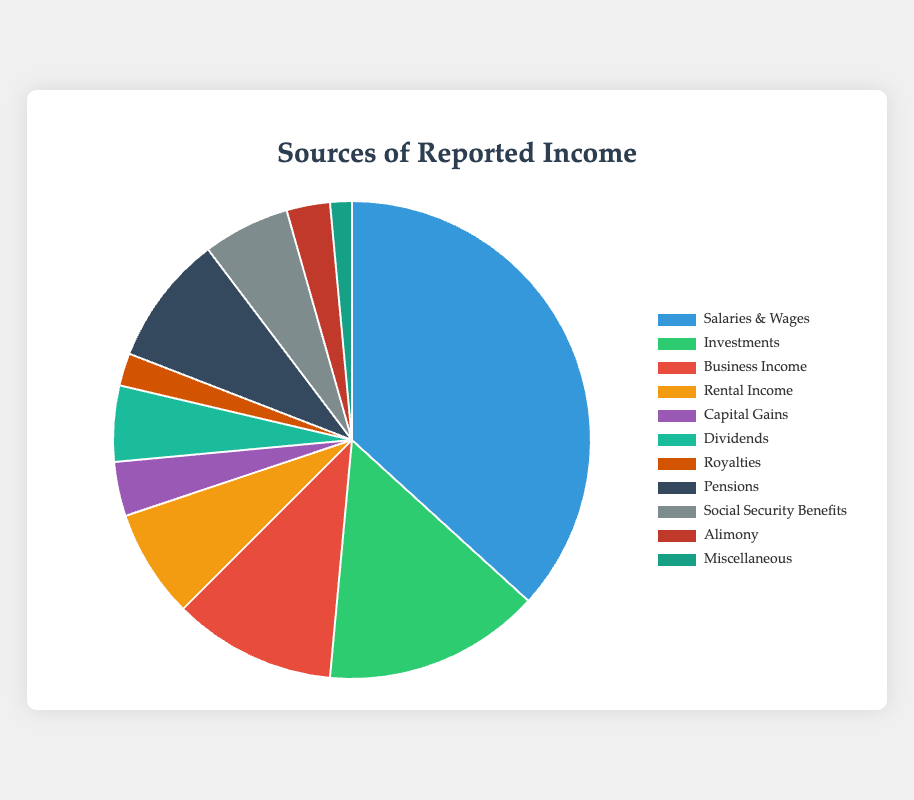What is the largest source of reported income? By looking at the pie chart, we can see that the largest segment belongs to "Salaries & Wages." This is indicated by the size of the corresponding slice.
Answer: Salaries & Wages What is the combined total of "Investments" and "Business Income"? The amount for "Investments" is $20,000 and for "Business Income" is $15,000. Adding these together gives $20,000 + $15,000 = $35,000.
Answer: $35,000 Which source contributes more, "Pensions" or "Social Security Benefits"? According to the chart, "Pensions" have an amount of $12,000, while "Social Security Benefits" have $8,000. Therefore, "Pensions" contribute more.
Answer: Pensions What is the total amount for all income sources? The total amount is the sum of all the reported amounts: $50,000 (Salaries & Wages) + $20,000 (Investments) + $15,000 (Business Income) + $10,000 (Rental Income) + $5,000 (Capital Gains) + $7,000 (Dividends) + $3,000 (Royalties) + $12,000 (Pensions) + $8,000 (Social Security Benefits) + $4,000 (Alimony) + $2,000 (Miscellaneous), which equals $136,000.
Answer: $136,000 What percentage of the total income is from "Business Income"? The total income is $136,000. The amount from "Business Income" is $15,000. The percentage is calculated as ($15,000 / $136,000) * 100 which equals approximately 11.03%.
Answer: 11.03% Which income source is represented by the green-colored slice? By examining the color-coded sections of the pie chart, we see that the green color represents "Investments."
Answer: Investments How much more income is reported from "Salaries & Wages" compared to "Pensions"? The amount from "Salaries & Wages" is $50,000, and from "Pensions," it is $12,000. The difference is $50,000 - $12,000 = $38,000.
Answer: $38,000 What is the average amount reported across all income sources? The total income is $136,000, and there are 11 different income sources. The average amount is $136,000 / 11, which equals approximately $12,364.
Answer: $12,364 How many income sources are less than $10,000? By examining the chart, the income sources with amounts less than $10,000 are "Capital Gains" ($5,000), "Dividends" ($7,000), "Royalties" ($3,000), "Social Security Benefits" ($8,000), "Alimony" ($4,000), and "Miscellaneous" ($2,000). There are 6 such sources.
Answer: 6 